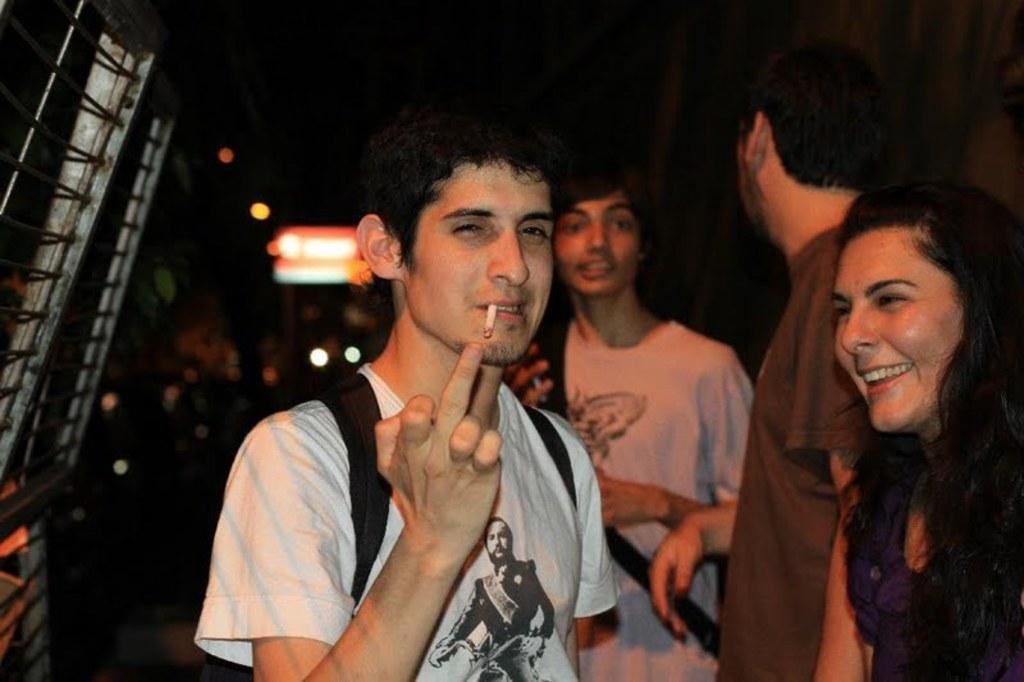Can you describe this image briefly? In this image I can see few people standing and wearing bags. Back I can see lights and a dark background. 